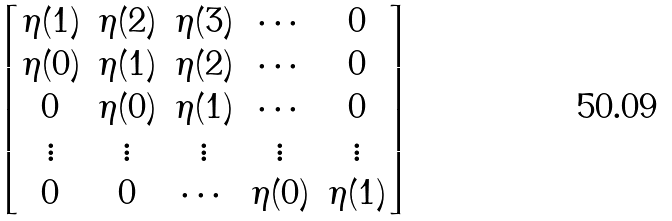Convert formula to latex. <formula><loc_0><loc_0><loc_500><loc_500>\begin{bmatrix} \eta ( 1 ) & \eta ( 2 ) & \eta ( 3 ) & \cdots & 0 \\ \eta ( 0 ) & \eta ( 1 ) & \eta ( 2 ) & \cdots & 0 \\ 0 & \eta ( 0 ) & \eta ( 1 ) & \cdots & 0 \\ \vdots & \vdots & \vdots & \vdots & \vdots \\ 0 & 0 & \cdots & \eta ( 0 ) & \eta ( 1 ) \end{bmatrix}</formula> 